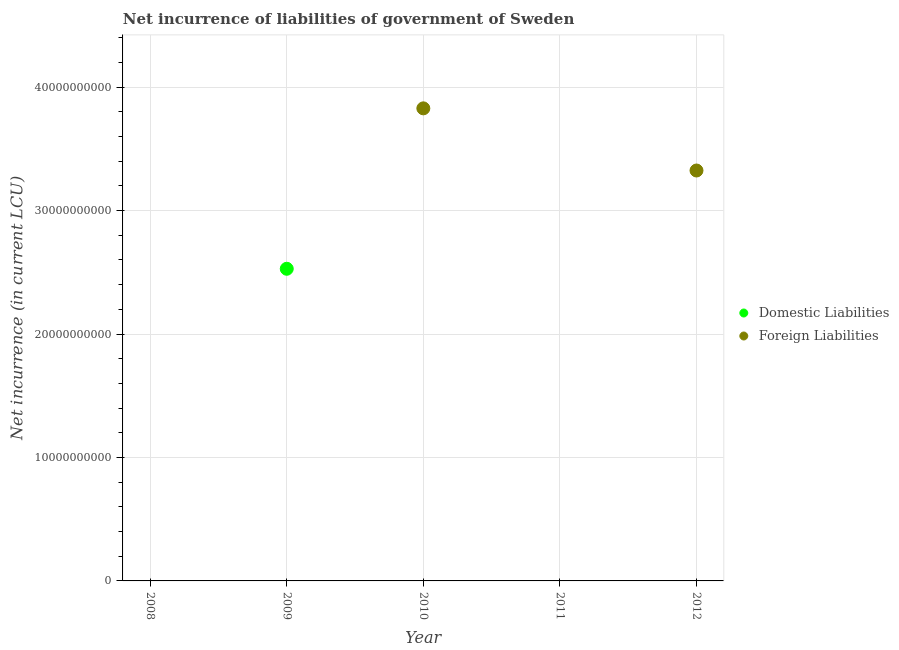Across all years, what is the maximum net incurrence of domestic liabilities?
Make the answer very short. 2.53e+1. In which year was the net incurrence of foreign liabilities maximum?
Give a very brief answer. 2010. What is the total net incurrence of foreign liabilities in the graph?
Keep it short and to the point. 7.15e+1. What is the difference between the net incurrence of foreign liabilities in 2010 and that in 2012?
Keep it short and to the point. 5.04e+09. What is the difference between the net incurrence of foreign liabilities in 2012 and the net incurrence of domestic liabilities in 2009?
Your answer should be compact. 7.96e+09. What is the average net incurrence of domestic liabilities per year?
Offer a very short reply. 5.06e+09. What is the difference between the highest and the lowest net incurrence of foreign liabilities?
Your response must be concise. 3.83e+1. Is the net incurrence of domestic liabilities strictly less than the net incurrence of foreign liabilities over the years?
Provide a short and direct response. No. How many dotlines are there?
Make the answer very short. 2. Are the values on the major ticks of Y-axis written in scientific E-notation?
Your answer should be very brief. No. Does the graph contain any zero values?
Make the answer very short. Yes. Does the graph contain grids?
Offer a very short reply. Yes. Where does the legend appear in the graph?
Your answer should be very brief. Center right. What is the title of the graph?
Your answer should be compact. Net incurrence of liabilities of government of Sweden. Does "Savings" appear as one of the legend labels in the graph?
Your response must be concise. No. What is the label or title of the Y-axis?
Offer a terse response. Net incurrence (in current LCU). What is the Net incurrence (in current LCU) in Domestic Liabilities in 2008?
Make the answer very short. 0. What is the Net incurrence (in current LCU) in Domestic Liabilities in 2009?
Your response must be concise. 2.53e+1. What is the Net incurrence (in current LCU) of Foreign Liabilities in 2009?
Your response must be concise. 0. What is the Net incurrence (in current LCU) in Foreign Liabilities in 2010?
Your answer should be very brief. 3.83e+1. What is the Net incurrence (in current LCU) in Foreign Liabilities in 2011?
Make the answer very short. 0. What is the Net incurrence (in current LCU) of Domestic Liabilities in 2012?
Your answer should be compact. 0. What is the Net incurrence (in current LCU) in Foreign Liabilities in 2012?
Your answer should be compact. 3.32e+1. Across all years, what is the maximum Net incurrence (in current LCU) in Domestic Liabilities?
Your answer should be compact. 2.53e+1. Across all years, what is the maximum Net incurrence (in current LCU) of Foreign Liabilities?
Your response must be concise. 3.83e+1. Across all years, what is the minimum Net incurrence (in current LCU) of Domestic Liabilities?
Your response must be concise. 0. What is the total Net incurrence (in current LCU) in Domestic Liabilities in the graph?
Ensure brevity in your answer.  2.53e+1. What is the total Net incurrence (in current LCU) of Foreign Liabilities in the graph?
Offer a terse response. 7.15e+1. What is the difference between the Net incurrence (in current LCU) of Foreign Liabilities in 2010 and that in 2012?
Provide a succinct answer. 5.04e+09. What is the difference between the Net incurrence (in current LCU) in Domestic Liabilities in 2009 and the Net incurrence (in current LCU) in Foreign Liabilities in 2010?
Give a very brief answer. -1.30e+1. What is the difference between the Net incurrence (in current LCU) of Domestic Liabilities in 2009 and the Net incurrence (in current LCU) of Foreign Liabilities in 2012?
Offer a terse response. -7.96e+09. What is the average Net incurrence (in current LCU) in Domestic Liabilities per year?
Provide a short and direct response. 5.06e+09. What is the average Net incurrence (in current LCU) in Foreign Liabilities per year?
Keep it short and to the point. 1.43e+1. What is the ratio of the Net incurrence (in current LCU) of Foreign Liabilities in 2010 to that in 2012?
Provide a short and direct response. 1.15. What is the difference between the highest and the lowest Net incurrence (in current LCU) of Domestic Liabilities?
Keep it short and to the point. 2.53e+1. What is the difference between the highest and the lowest Net incurrence (in current LCU) in Foreign Liabilities?
Provide a succinct answer. 3.83e+1. 